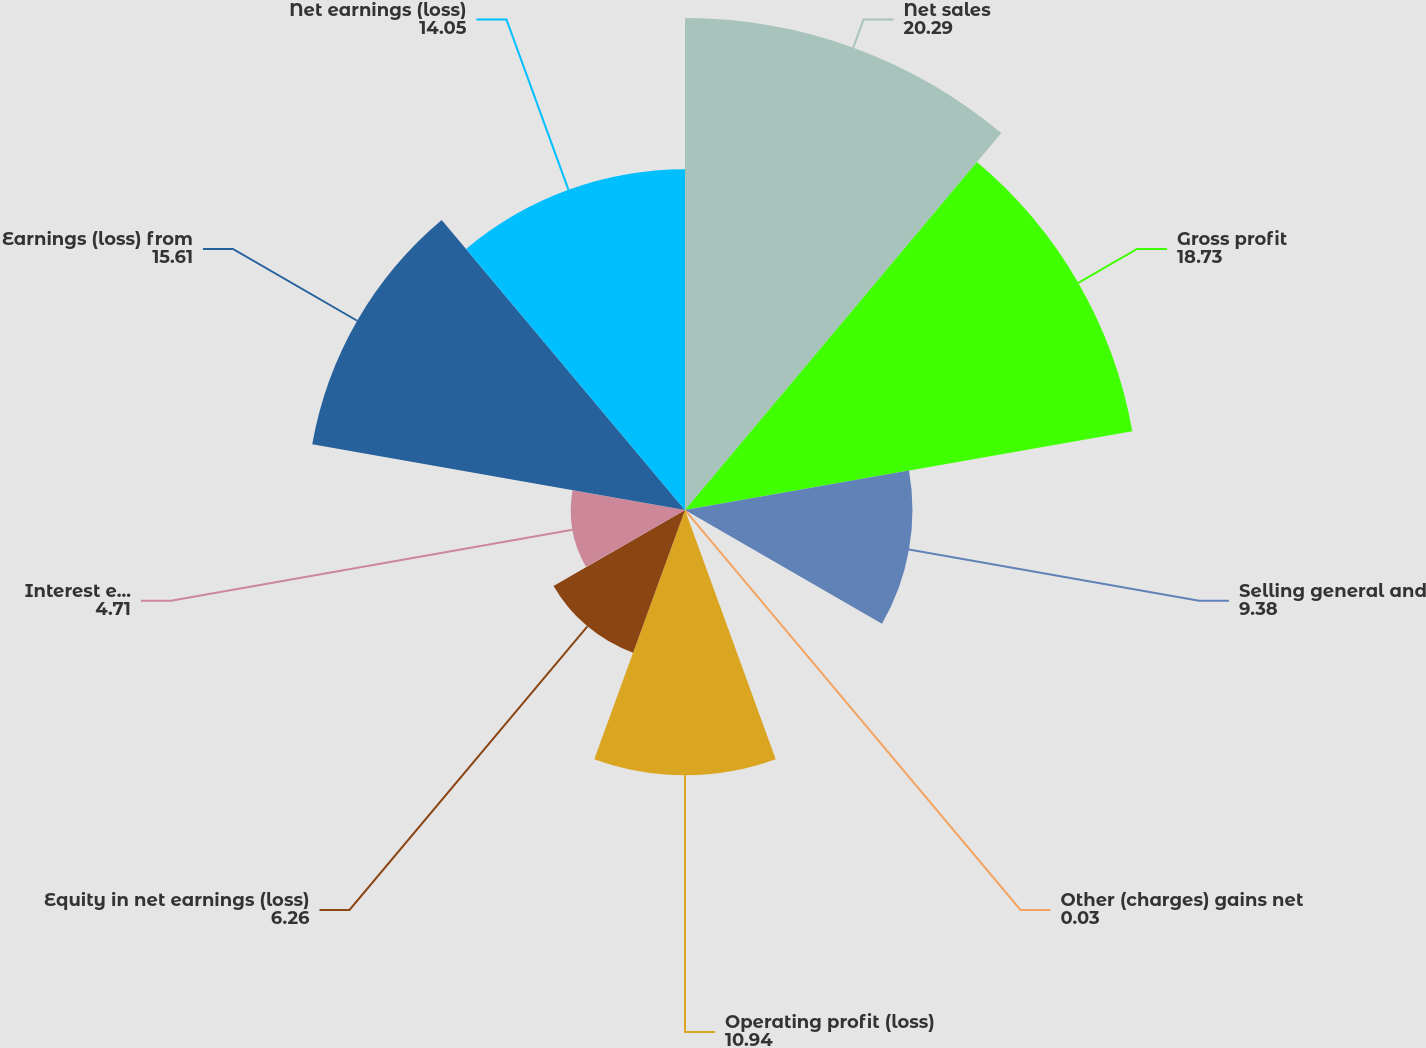Convert chart to OTSL. <chart><loc_0><loc_0><loc_500><loc_500><pie_chart><fcel>Net sales<fcel>Gross profit<fcel>Selling general and<fcel>Other (charges) gains net<fcel>Operating profit (loss)<fcel>Equity in net earnings (loss)<fcel>Interest expense<fcel>Earnings (loss) from<fcel>Net earnings (loss)<nl><fcel>20.29%<fcel>18.73%<fcel>9.38%<fcel>0.03%<fcel>10.94%<fcel>6.26%<fcel>4.71%<fcel>15.61%<fcel>14.05%<nl></chart> 